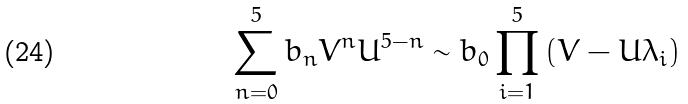<formula> <loc_0><loc_0><loc_500><loc_500>\sum _ { n = 0 } ^ { 5 } b _ { n } V ^ { n } U ^ { 5 - n } \sim b _ { 0 } \prod _ { i = 1 } ^ { 5 } \left ( V - U \lambda _ { i } \right )</formula> 